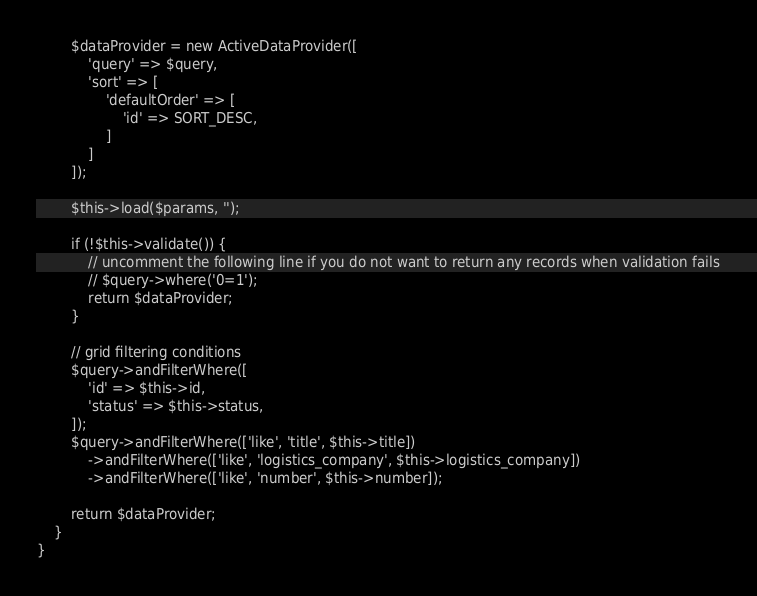<code> <loc_0><loc_0><loc_500><loc_500><_PHP_>
        $dataProvider = new ActiveDataProvider([
            'query' => $query,
            'sort' => [
                'defaultOrder' => [
                    'id' => SORT_DESC,
                ]
            ]
        ]);

        $this->load($params, '');

        if (!$this->validate()) {
            // uncomment the following line if you do not want to return any records when validation fails
            // $query->where('0=1');
            return $dataProvider;
        }

        // grid filtering conditions
        $query->andFilterWhere([
            'id' => $this->id,
            'status' => $this->status,
        ]);
        $query->andFilterWhere(['like', 'title', $this->title])
            ->andFilterWhere(['like', 'logistics_company', $this->logistics_company])
            ->andFilterWhere(['like', 'number', $this->number]);

        return $dataProvider;
    }
}</code> 